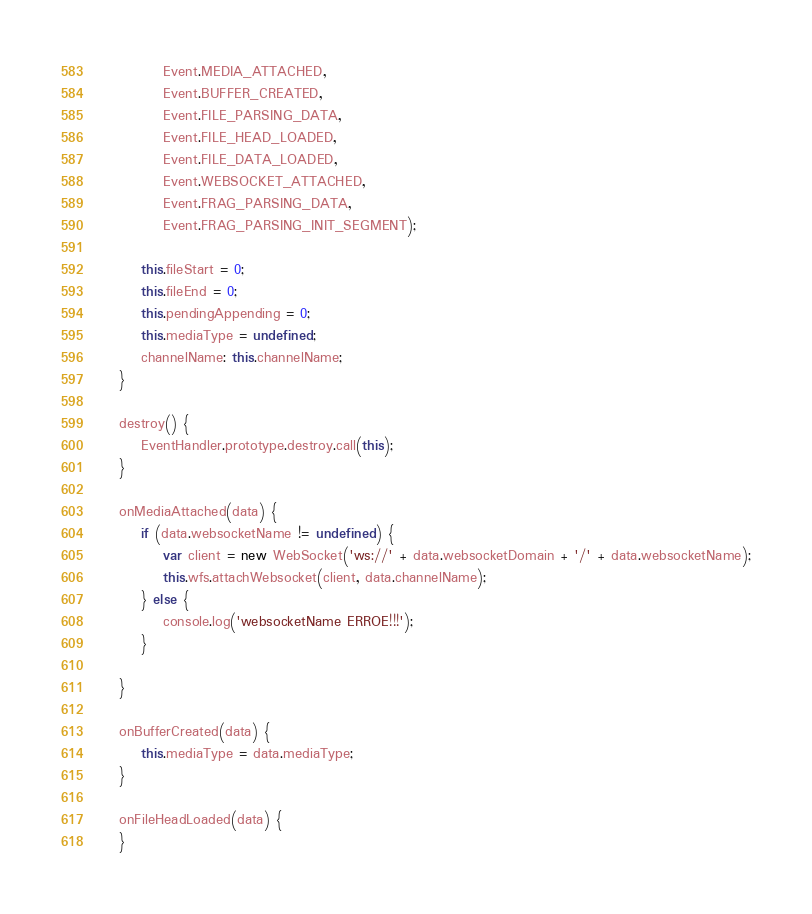<code> <loc_0><loc_0><loc_500><loc_500><_JavaScript_>            Event.MEDIA_ATTACHED,
            Event.BUFFER_CREATED,
            Event.FILE_PARSING_DATA,
            Event.FILE_HEAD_LOADED,
            Event.FILE_DATA_LOADED,
            Event.WEBSOCKET_ATTACHED,
            Event.FRAG_PARSING_DATA,
            Event.FRAG_PARSING_INIT_SEGMENT);

        this.fileStart = 0;
        this.fileEnd = 0;
        this.pendingAppending = 0;
        this.mediaType = undefined;
        channelName: this.channelName;
    }

    destroy() {
        EventHandler.prototype.destroy.call(this);
    }

    onMediaAttached(data) {
        if (data.websocketName != undefined) {
            var client = new WebSocket('ws://' + data.websocketDomain + '/' + data.websocketName);
            this.wfs.attachWebsocket(client, data.channelName);
        } else {
            console.log('websocketName ERROE!!!');
        }

    }

    onBufferCreated(data) {
        this.mediaType = data.mediaType;
    }

    onFileHeadLoaded(data) {
    }
</code> 